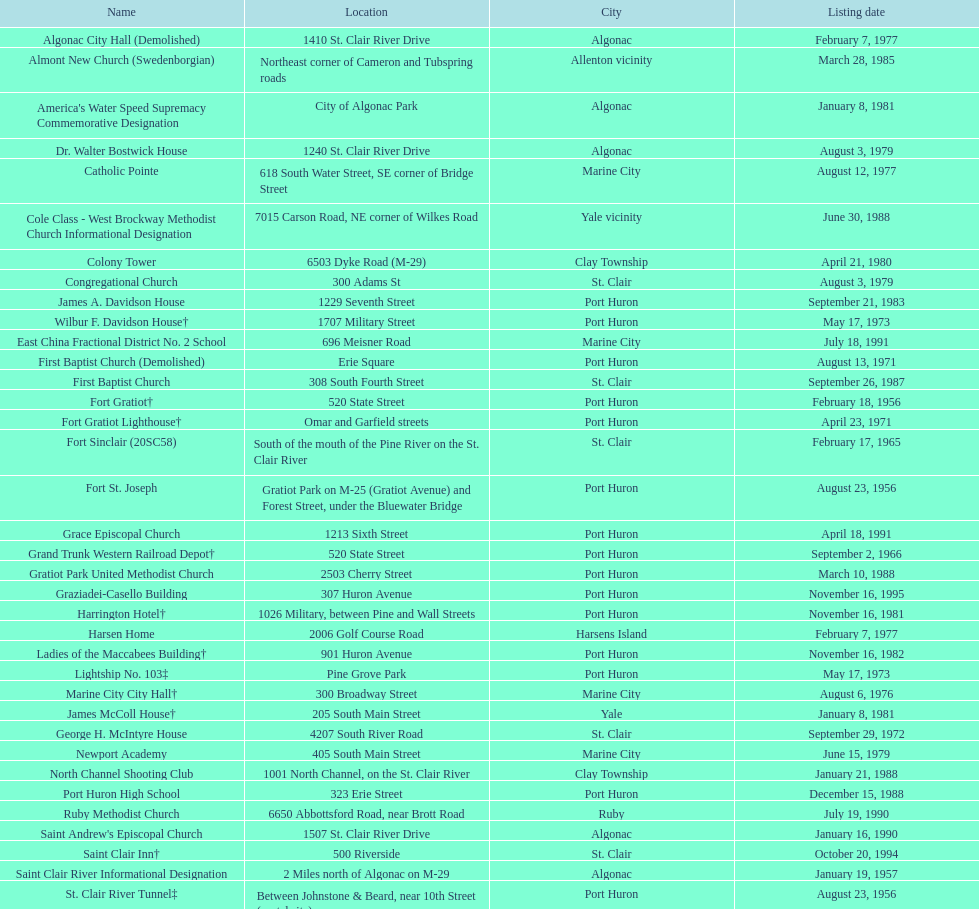Which metropolis has the highest count of historic locations, preserved or destroyed? Port Huron. 